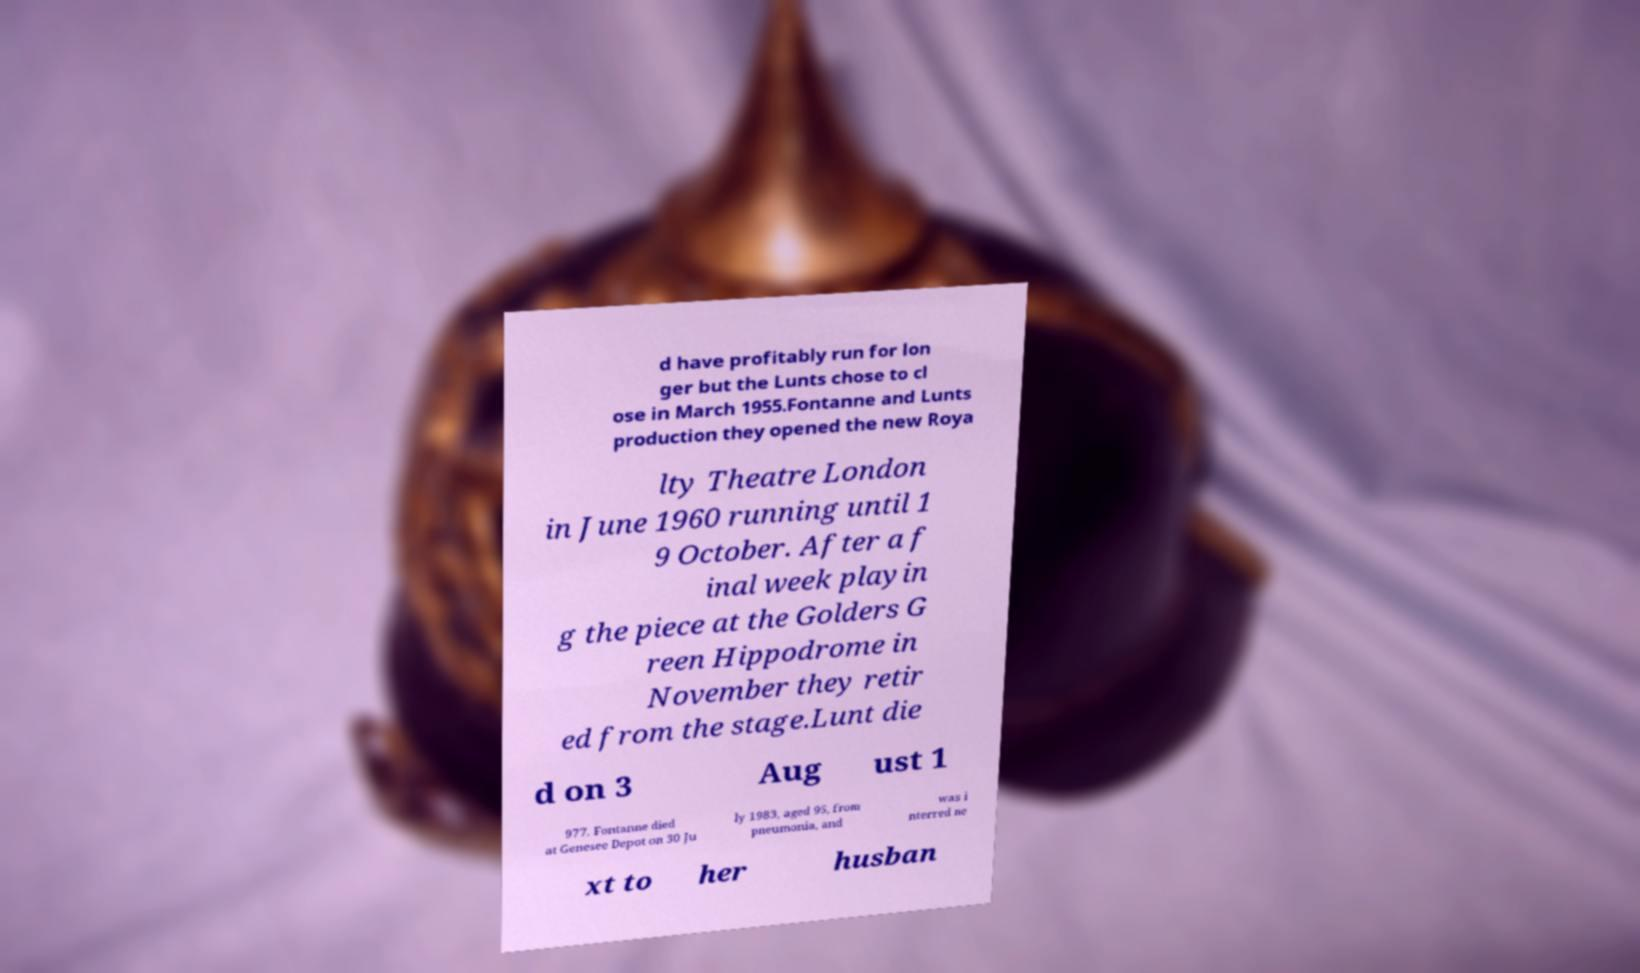Please identify and transcribe the text found in this image. d have profitably run for lon ger but the Lunts chose to cl ose in March 1955.Fontanne and Lunts production they opened the new Roya lty Theatre London in June 1960 running until 1 9 October. After a f inal week playin g the piece at the Golders G reen Hippodrome in November they retir ed from the stage.Lunt die d on 3 Aug ust 1 977. Fontanne died at Genesee Depot on 30 Ju ly 1983, aged 95, from pneumonia, and was i nterred ne xt to her husban 